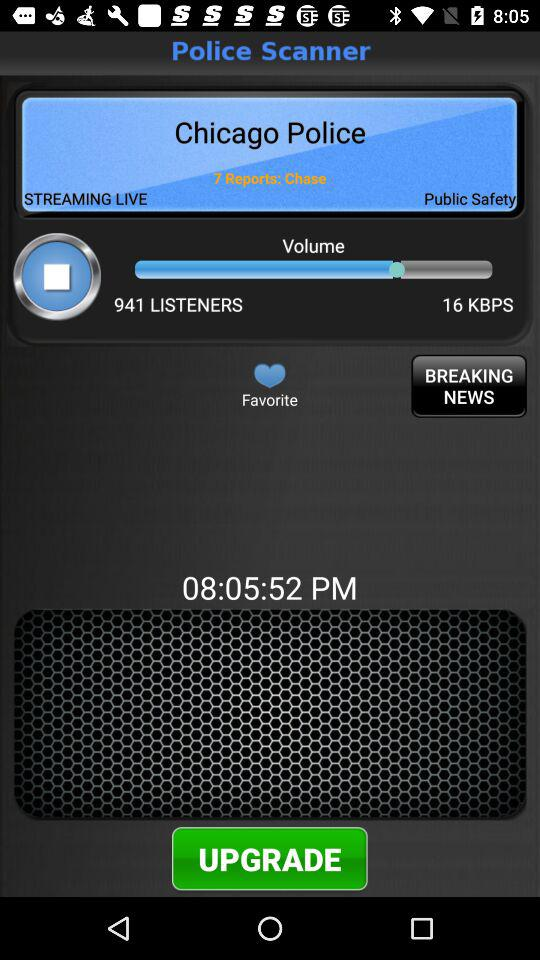How many text elements show the name of the police department?
Answer the question using a single word or phrase. 2 